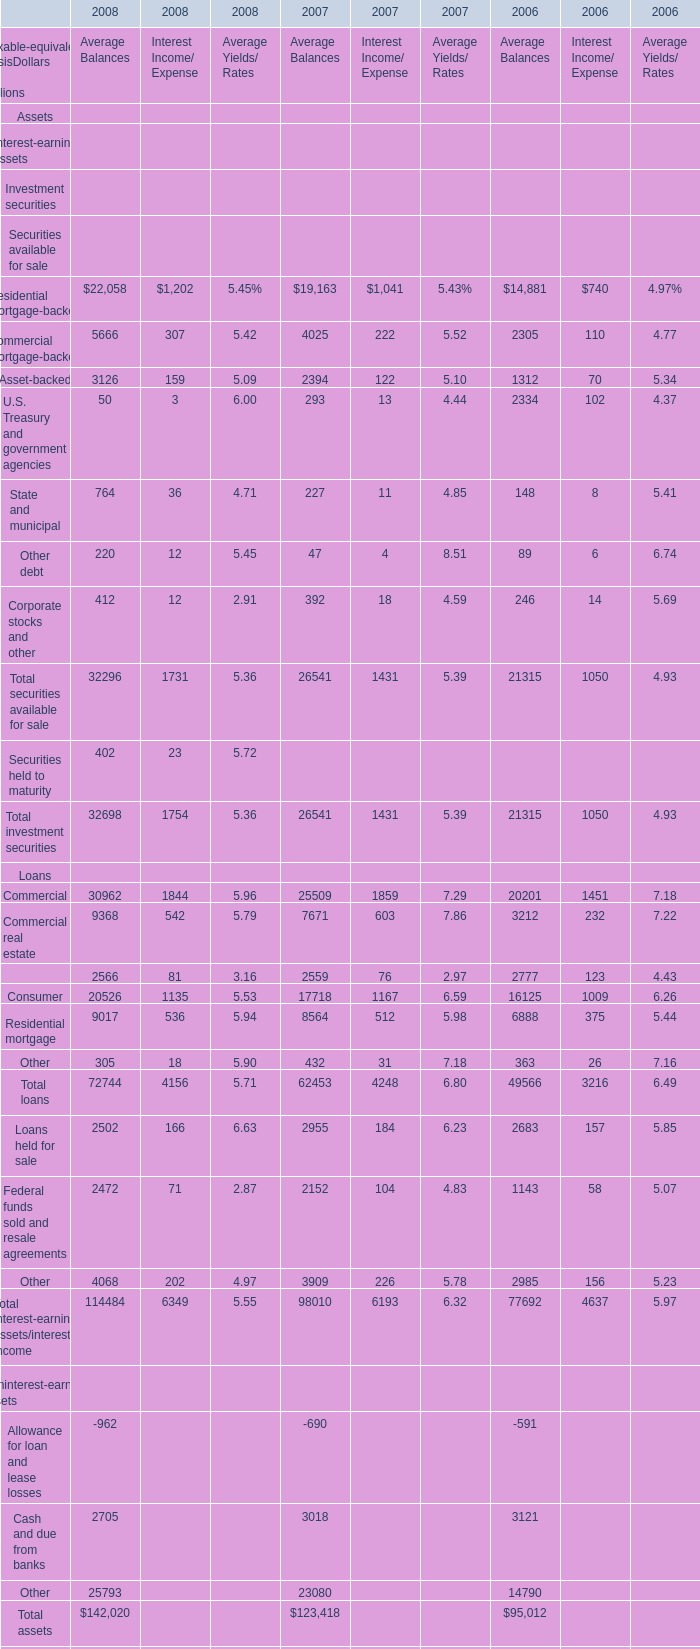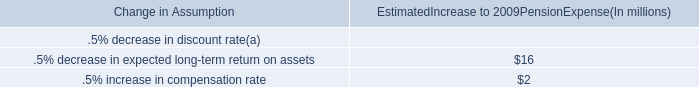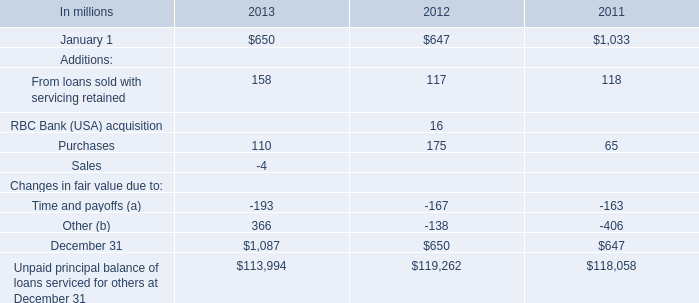what was the change in the expected long-term return on plan assets for determining net periodic pension cost in 2008 compared to 2007? 
Computations: (8.25 - 8.25)
Answer: 0.0. 